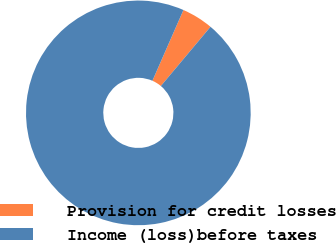<chart> <loc_0><loc_0><loc_500><loc_500><pie_chart><fcel>Provision for credit losses<fcel>Income (loss)before taxes<nl><fcel>4.53%<fcel>95.47%<nl></chart> 